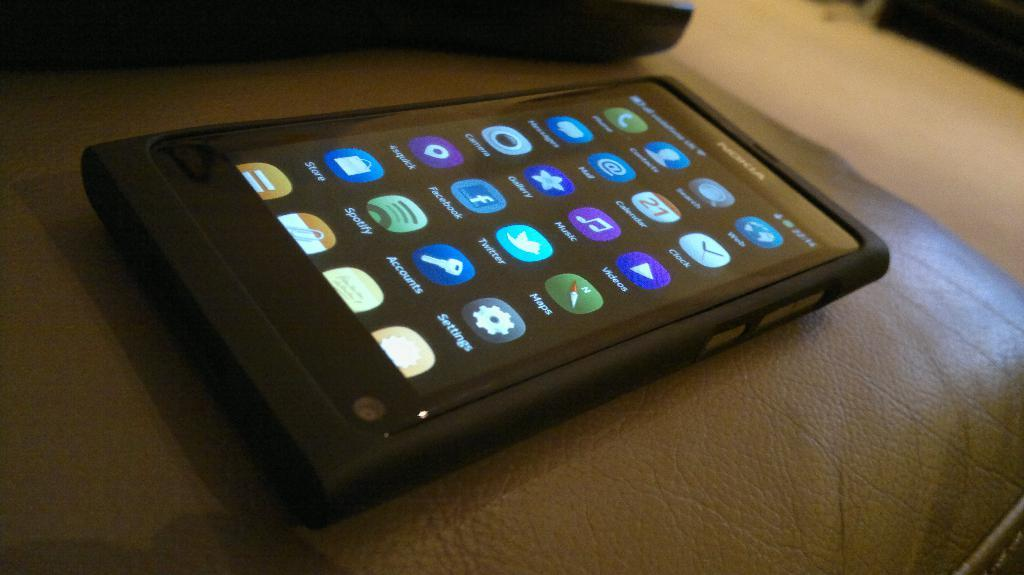<image>
Create a compact narrative representing the image presented. a black nokia phone with the spotify app logo on the screen 